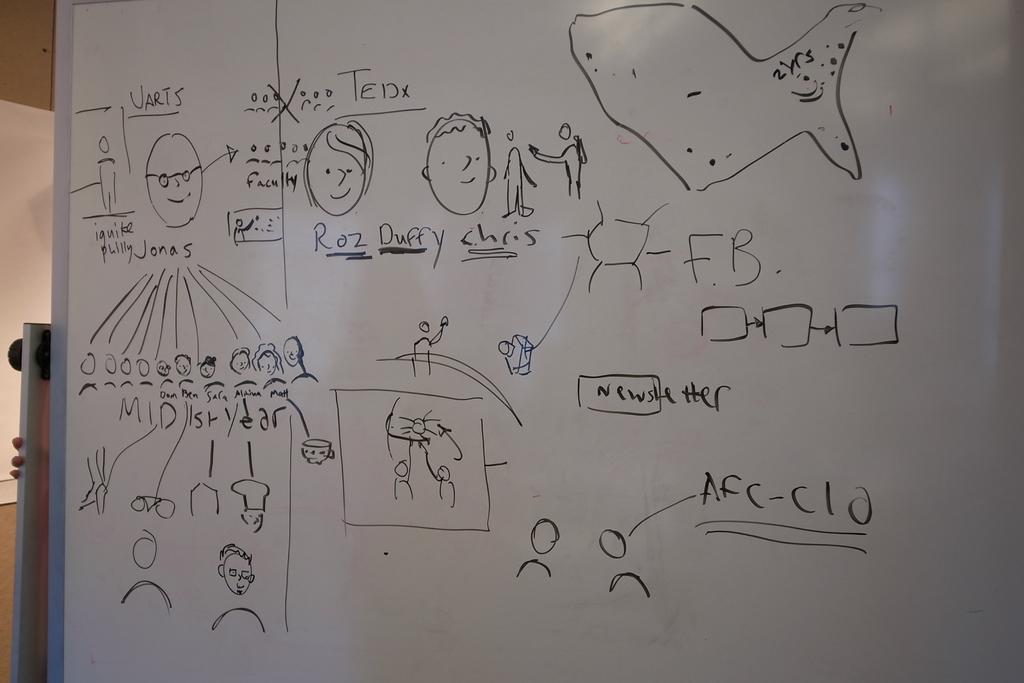Provide a one-sentence caption for the provided image. Drawing on a white board in black marker of Roz Duffy Chris. 